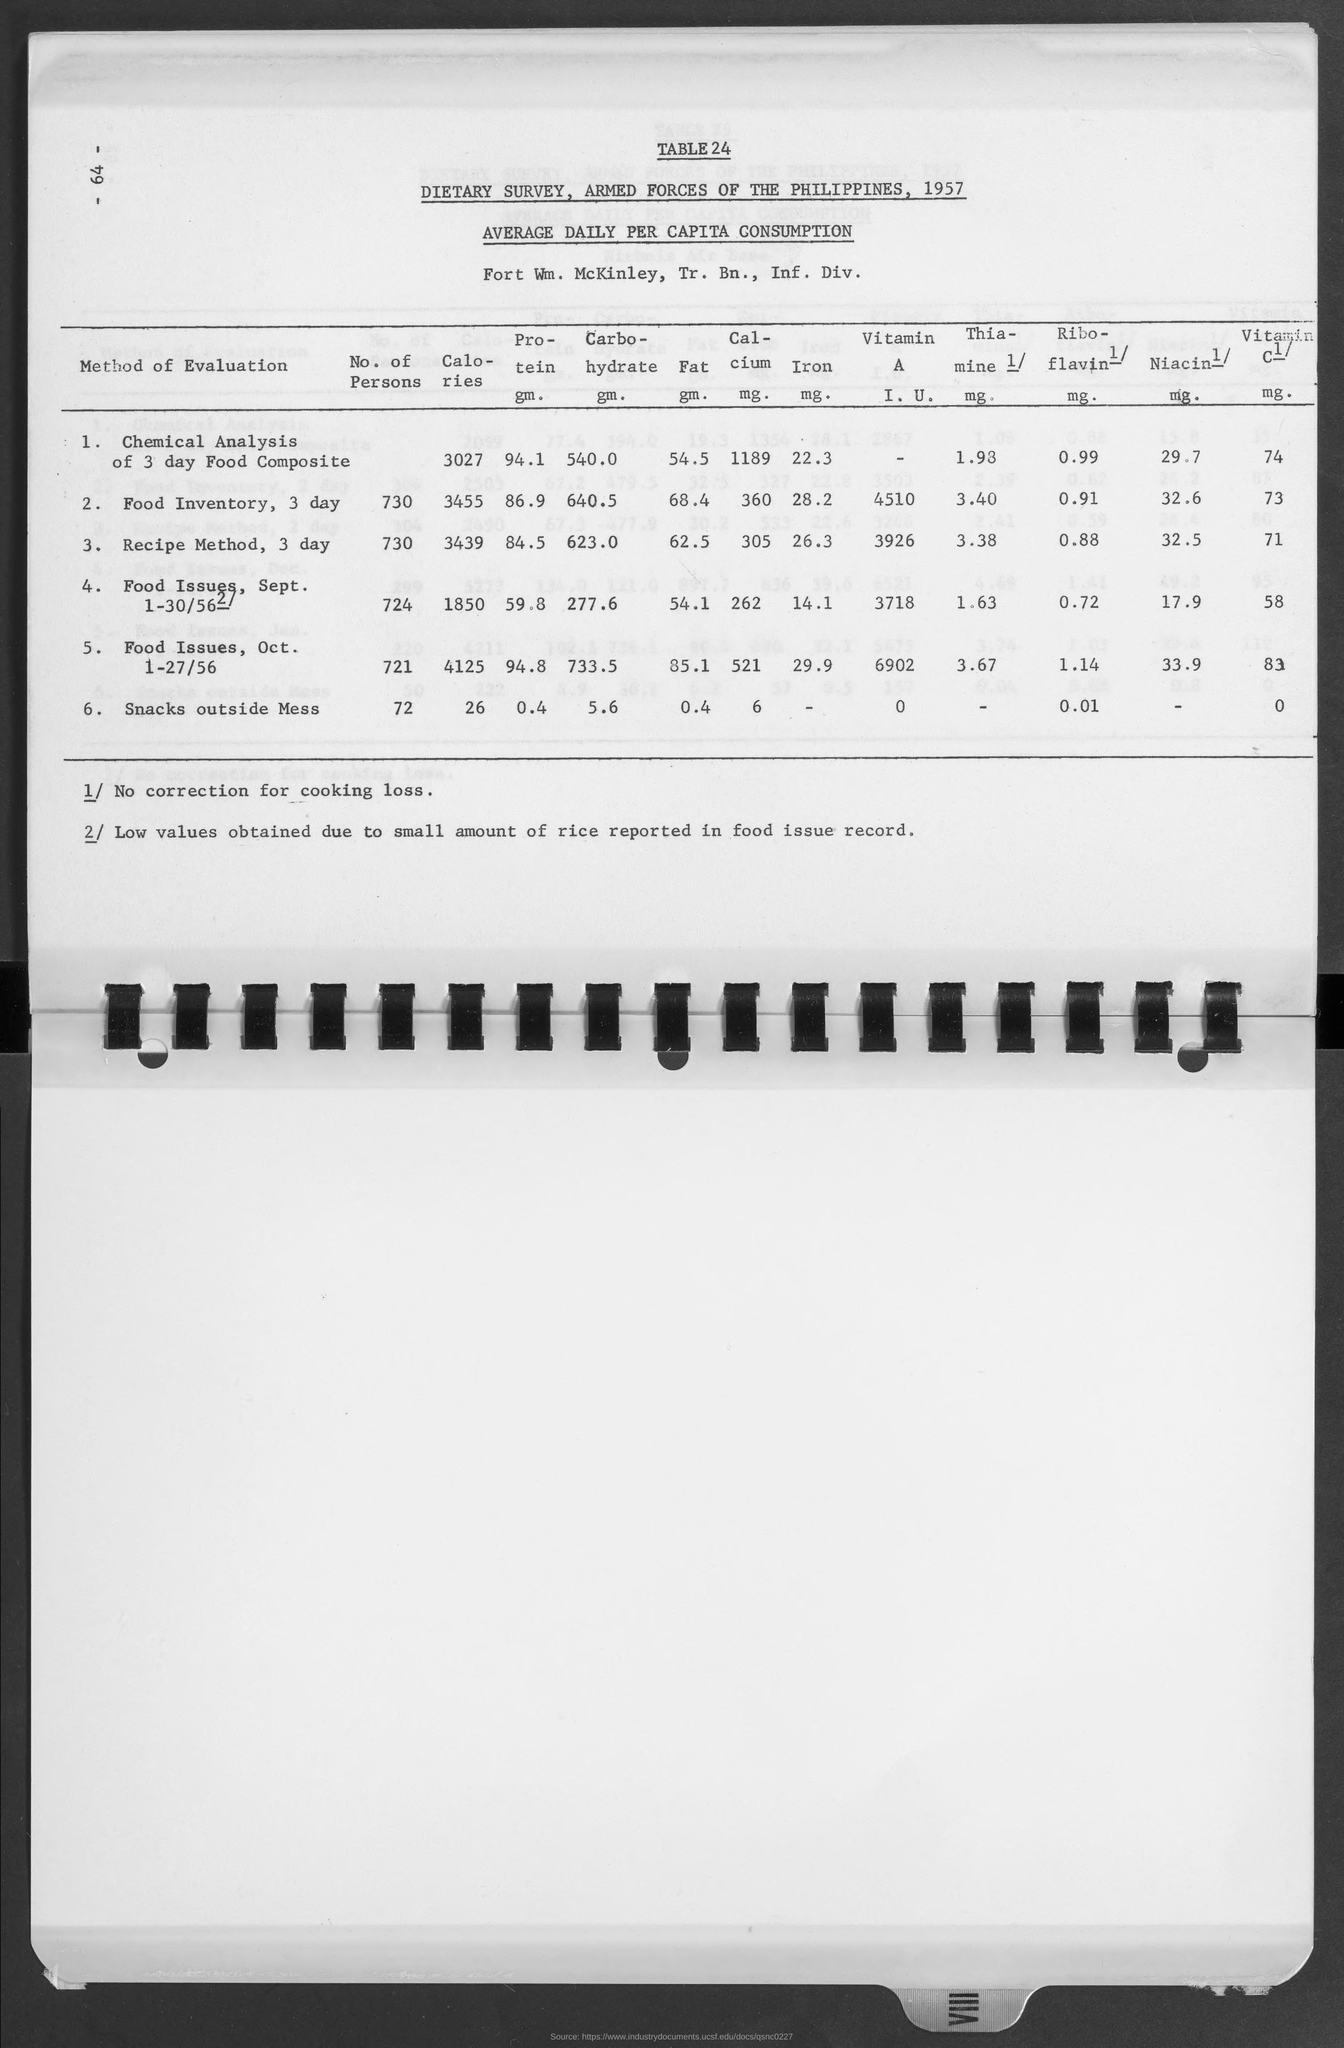List a handful of essential elements in this visual. What is the table number? It is table 24, also known as table24... The amount of calories for snacks outside the mess is 26. The amount of calories for Food Issues is 4125. The amount of protein for the chemical analysis of a 3-day food composite is 94.1 grams. The amount of calories for the current food inventory over the next three days is 3455. 